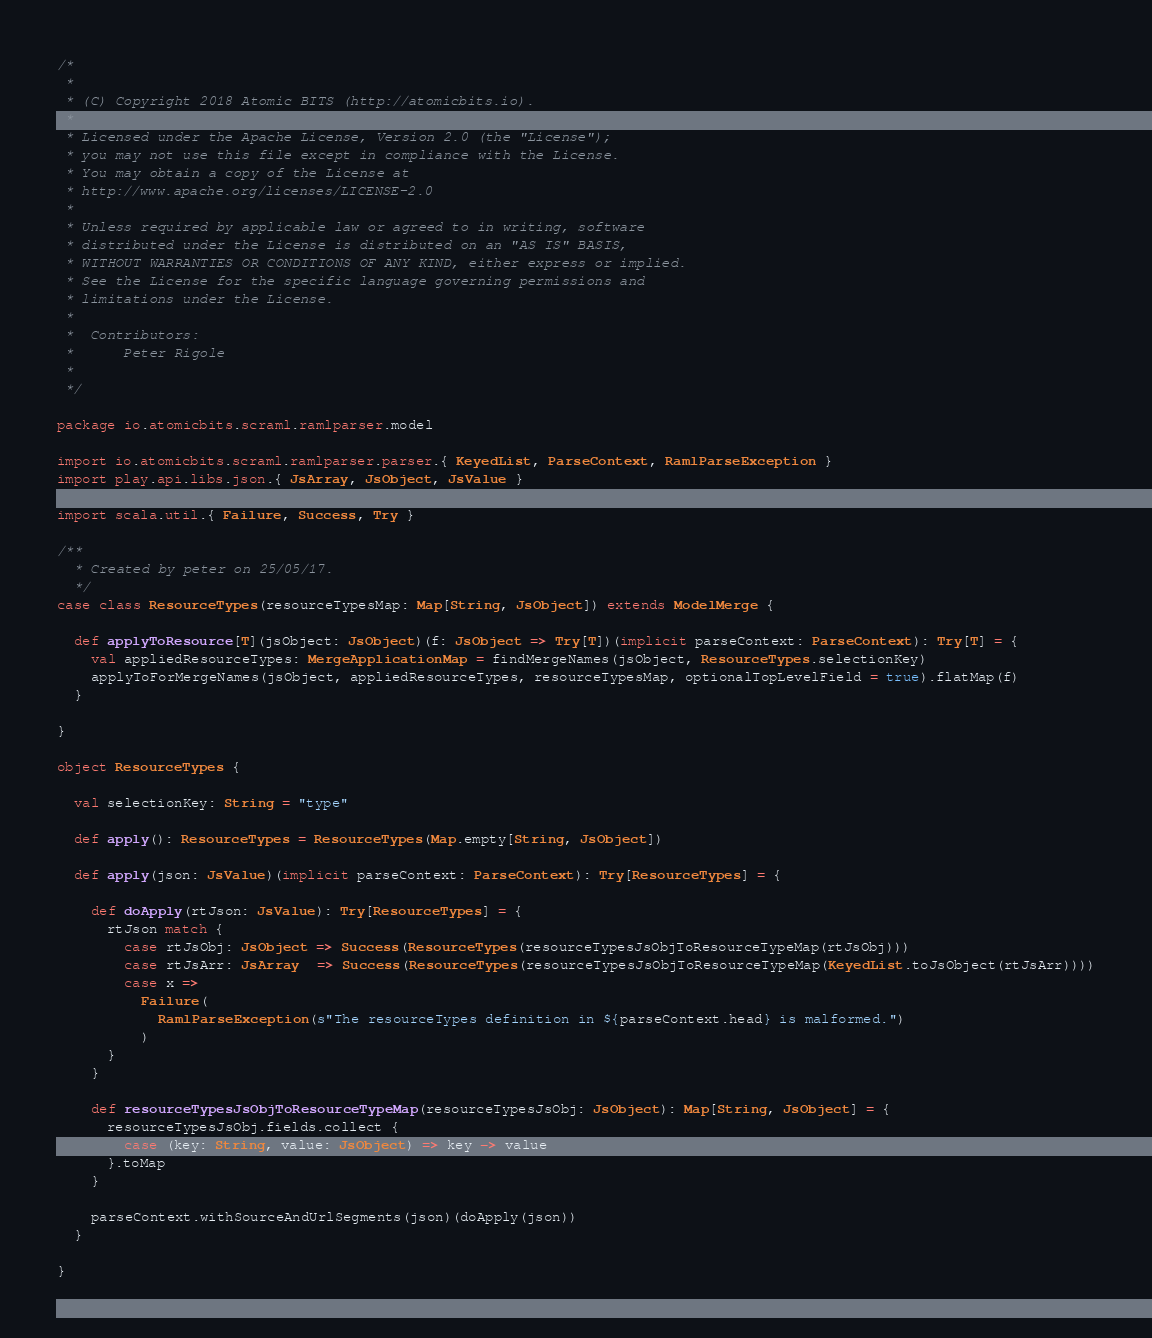Convert code to text. <code><loc_0><loc_0><loc_500><loc_500><_Scala_>/*
 *
 * (C) Copyright 2018 Atomic BITS (http://atomicbits.io).
 *
 * Licensed under the Apache License, Version 2.0 (the "License");
 * you may not use this file except in compliance with the License.
 * You may obtain a copy of the License at
 * http://www.apache.org/licenses/LICENSE-2.0
 *
 * Unless required by applicable law or agreed to in writing, software
 * distributed under the License is distributed on an "AS IS" BASIS,
 * WITHOUT WARRANTIES OR CONDITIONS OF ANY KIND, either express or implied.
 * See the License for the specific language governing permissions and
 * limitations under the License.
 *
 *  Contributors:
 *      Peter Rigole
 *
 */

package io.atomicbits.scraml.ramlparser.model

import io.atomicbits.scraml.ramlparser.parser.{ KeyedList, ParseContext, RamlParseException }
import play.api.libs.json.{ JsArray, JsObject, JsValue }

import scala.util.{ Failure, Success, Try }

/**
  * Created by peter on 25/05/17.
  */
case class ResourceTypes(resourceTypesMap: Map[String, JsObject]) extends ModelMerge {

  def applyToResource[T](jsObject: JsObject)(f: JsObject => Try[T])(implicit parseContext: ParseContext): Try[T] = {
    val appliedResourceTypes: MergeApplicationMap = findMergeNames(jsObject, ResourceTypes.selectionKey)
    applyToForMergeNames(jsObject, appliedResourceTypes, resourceTypesMap, optionalTopLevelField = true).flatMap(f)
  }

}

object ResourceTypes {

  val selectionKey: String = "type"

  def apply(): ResourceTypes = ResourceTypes(Map.empty[String, JsObject])

  def apply(json: JsValue)(implicit parseContext: ParseContext): Try[ResourceTypes] = {

    def doApply(rtJson: JsValue): Try[ResourceTypes] = {
      rtJson match {
        case rtJsObj: JsObject => Success(ResourceTypes(resourceTypesJsObjToResourceTypeMap(rtJsObj)))
        case rtJsArr: JsArray  => Success(ResourceTypes(resourceTypesJsObjToResourceTypeMap(KeyedList.toJsObject(rtJsArr))))
        case x =>
          Failure(
            RamlParseException(s"The resourceTypes definition in ${parseContext.head} is malformed.")
          )
      }
    }

    def resourceTypesJsObjToResourceTypeMap(resourceTypesJsObj: JsObject): Map[String, JsObject] = {
      resourceTypesJsObj.fields.collect {
        case (key: String, value: JsObject) => key -> value
      }.toMap
    }

    parseContext.withSourceAndUrlSegments(json)(doApply(json))
  }

}
</code> 